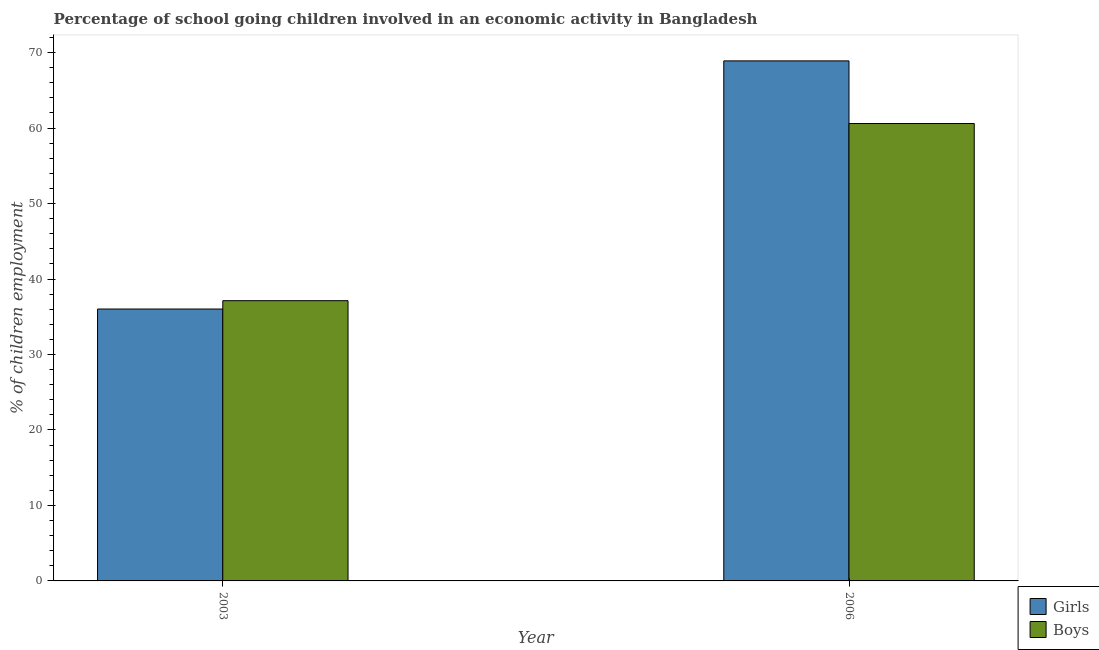How many different coloured bars are there?
Offer a very short reply. 2. How many groups of bars are there?
Provide a succinct answer. 2. Are the number of bars on each tick of the X-axis equal?
Offer a very short reply. Yes. How many bars are there on the 2nd tick from the left?
Your response must be concise. 2. How many bars are there on the 2nd tick from the right?
Ensure brevity in your answer.  2. What is the percentage of school going boys in 2006?
Provide a short and direct response. 60.6. Across all years, what is the maximum percentage of school going girls?
Your answer should be compact. 68.9. Across all years, what is the minimum percentage of school going boys?
Provide a succinct answer. 37.13. What is the total percentage of school going boys in the graph?
Make the answer very short. 97.73. What is the difference between the percentage of school going boys in 2003 and that in 2006?
Your response must be concise. -23.47. What is the difference between the percentage of school going girls in 2006 and the percentage of school going boys in 2003?
Offer a terse response. 32.88. What is the average percentage of school going boys per year?
Ensure brevity in your answer.  48.86. In the year 2003, what is the difference between the percentage of school going boys and percentage of school going girls?
Provide a succinct answer. 0. What is the ratio of the percentage of school going girls in 2003 to that in 2006?
Give a very brief answer. 0.52. In how many years, is the percentage of school going girls greater than the average percentage of school going girls taken over all years?
Make the answer very short. 1. What does the 1st bar from the left in 2006 represents?
Make the answer very short. Girls. What does the 2nd bar from the right in 2003 represents?
Keep it short and to the point. Girls. Are all the bars in the graph horizontal?
Offer a terse response. No. What is the difference between two consecutive major ticks on the Y-axis?
Make the answer very short. 10. Are the values on the major ticks of Y-axis written in scientific E-notation?
Provide a short and direct response. No. Does the graph contain any zero values?
Offer a very short reply. No. Does the graph contain grids?
Offer a very short reply. No. How are the legend labels stacked?
Provide a short and direct response. Vertical. What is the title of the graph?
Keep it short and to the point. Percentage of school going children involved in an economic activity in Bangladesh. What is the label or title of the X-axis?
Your response must be concise. Year. What is the label or title of the Y-axis?
Give a very brief answer. % of children employment. What is the % of children employment in Girls in 2003?
Make the answer very short. 36.02. What is the % of children employment in Boys in 2003?
Make the answer very short. 37.13. What is the % of children employment of Girls in 2006?
Provide a short and direct response. 68.9. What is the % of children employment in Boys in 2006?
Give a very brief answer. 60.6. Across all years, what is the maximum % of children employment of Girls?
Keep it short and to the point. 68.9. Across all years, what is the maximum % of children employment of Boys?
Offer a very short reply. 60.6. Across all years, what is the minimum % of children employment of Girls?
Make the answer very short. 36.02. Across all years, what is the minimum % of children employment in Boys?
Offer a very short reply. 37.13. What is the total % of children employment of Girls in the graph?
Give a very brief answer. 104.92. What is the total % of children employment in Boys in the graph?
Provide a succinct answer. 97.73. What is the difference between the % of children employment in Girls in 2003 and that in 2006?
Make the answer very short. -32.88. What is the difference between the % of children employment of Boys in 2003 and that in 2006?
Provide a short and direct response. -23.47. What is the difference between the % of children employment of Girls in 2003 and the % of children employment of Boys in 2006?
Your response must be concise. -24.58. What is the average % of children employment of Girls per year?
Offer a terse response. 52.46. What is the average % of children employment of Boys per year?
Your answer should be very brief. 48.86. In the year 2003, what is the difference between the % of children employment of Girls and % of children employment of Boys?
Offer a terse response. -1.11. What is the ratio of the % of children employment in Girls in 2003 to that in 2006?
Your response must be concise. 0.52. What is the ratio of the % of children employment of Boys in 2003 to that in 2006?
Your answer should be compact. 0.61. What is the difference between the highest and the second highest % of children employment in Girls?
Provide a short and direct response. 32.88. What is the difference between the highest and the second highest % of children employment in Boys?
Provide a succinct answer. 23.47. What is the difference between the highest and the lowest % of children employment in Girls?
Ensure brevity in your answer.  32.88. What is the difference between the highest and the lowest % of children employment of Boys?
Offer a terse response. 23.47. 